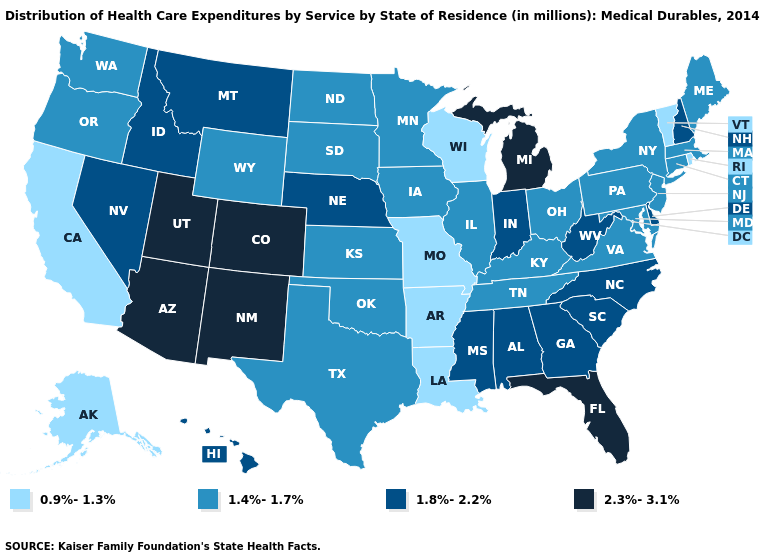What is the lowest value in states that border Washington?
Give a very brief answer. 1.4%-1.7%. What is the value of Virginia?
Be succinct. 1.4%-1.7%. Does the first symbol in the legend represent the smallest category?
Write a very short answer. Yes. What is the lowest value in the USA?
Write a very short answer. 0.9%-1.3%. Does Nevada have the lowest value in the West?
Quick response, please. No. Name the states that have a value in the range 1.8%-2.2%?
Answer briefly. Alabama, Delaware, Georgia, Hawaii, Idaho, Indiana, Mississippi, Montana, Nebraska, Nevada, New Hampshire, North Carolina, South Carolina, West Virginia. What is the value of Kentucky?
Be succinct. 1.4%-1.7%. Name the states that have a value in the range 1.4%-1.7%?
Answer briefly. Connecticut, Illinois, Iowa, Kansas, Kentucky, Maine, Maryland, Massachusetts, Minnesota, New Jersey, New York, North Dakota, Ohio, Oklahoma, Oregon, Pennsylvania, South Dakota, Tennessee, Texas, Virginia, Washington, Wyoming. Name the states that have a value in the range 1.4%-1.7%?
Write a very short answer. Connecticut, Illinois, Iowa, Kansas, Kentucky, Maine, Maryland, Massachusetts, Minnesota, New Jersey, New York, North Dakota, Ohio, Oklahoma, Oregon, Pennsylvania, South Dakota, Tennessee, Texas, Virginia, Washington, Wyoming. What is the value of Ohio?
Quick response, please. 1.4%-1.7%. Which states have the lowest value in the Northeast?
Concise answer only. Rhode Island, Vermont. Name the states that have a value in the range 1.8%-2.2%?
Answer briefly. Alabama, Delaware, Georgia, Hawaii, Idaho, Indiana, Mississippi, Montana, Nebraska, Nevada, New Hampshire, North Carolina, South Carolina, West Virginia. What is the lowest value in the MidWest?
Short answer required. 0.9%-1.3%. Among the states that border Minnesota , which have the lowest value?
Write a very short answer. Wisconsin. 